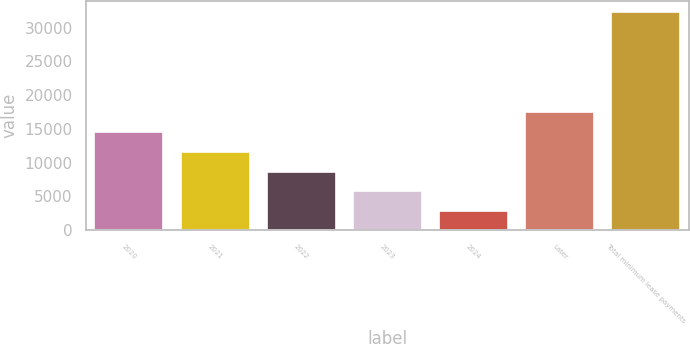Convert chart. <chart><loc_0><loc_0><loc_500><loc_500><bar_chart><fcel>2020<fcel>2021<fcel>2022<fcel>2023<fcel>2024<fcel>Later<fcel>Total minimum lease payments<nl><fcel>14569.8<fcel>11620.1<fcel>8670.4<fcel>5720.7<fcel>2771<fcel>17519.5<fcel>32268<nl></chart> 